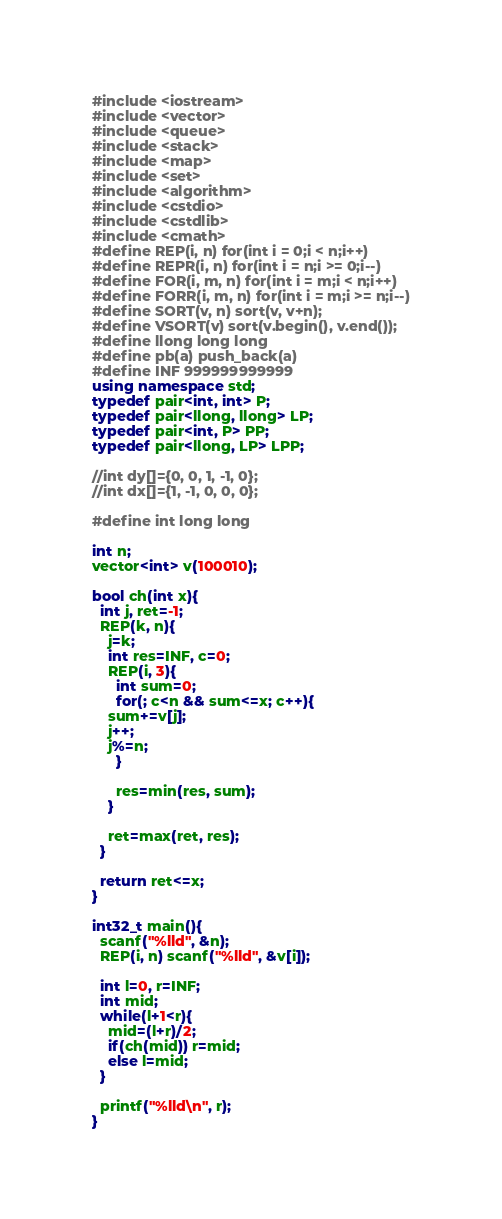<code> <loc_0><loc_0><loc_500><loc_500><_C++_>#include <iostream>
#include <vector>
#include <queue>
#include <stack>
#include <map>
#include <set>
#include <algorithm>
#include <cstdio>
#include <cstdlib>
#include <cmath>
#define REP(i, n) for(int i = 0;i < n;i++)
#define REPR(i, n) for(int i = n;i >= 0;i--)
#define FOR(i, m, n) for(int i = m;i < n;i++)
#define FORR(i, m, n) for(int i = m;i >= n;i--)
#define SORT(v, n) sort(v, v+n);
#define VSORT(v) sort(v.begin(), v.end());
#define llong long long
#define pb(a) push_back(a)
#define INF 999999999999
using namespace std;
typedef pair<int, int> P;
typedef pair<llong, llong> LP;
typedef pair<int, P> PP;
typedef pair<llong, LP> LPP;

//int dy[]={0, 0, 1, -1, 0};
//int dx[]={1, -1, 0, 0, 0};

#define int long long

int n;
vector<int> v(100010);

bool ch(int x){
  int j, ret=-1;
  REP(k, n){
    j=k;
    int res=INF, c=0;
    REP(i, 3){
      int sum=0;
      for(; c<n && sum<=x; c++){
	sum+=v[j];
	j++;
	j%=n;
      }

      res=min(res, sum);
    }
    
    ret=max(ret, res);
  }

  return ret<=x;
}

int32_t main(){
  scanf("%lld", &n);
  REP(i, n) scanf("%lld", &v[i]);

  int l=0, r=INF;
  int mid;
  while(l+1<r){
    mid=(l+r)/2;
    if(ch(mid)) r=mid;
    else l=mid;
  }

  printf("%lld\n", r);
}</code> 